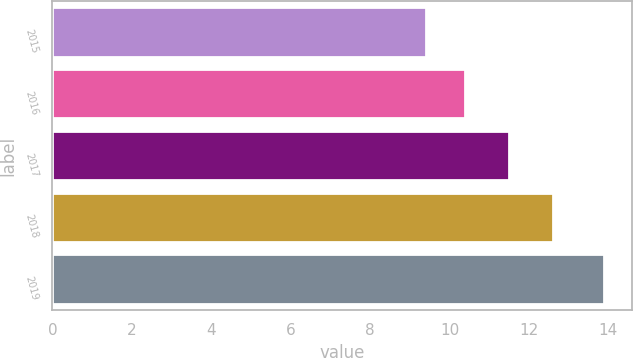<chart> <loc_0><loc_0><loc_500><loc_500><bar_chart><fcel>2015<fcel>2016<fcel>2017<fcel>2018<fcel>2019<nl><fcel>9.4<fcel>10.4<fcel>11.5<fcel>12.6<fcel>13.9<nl></chart> 